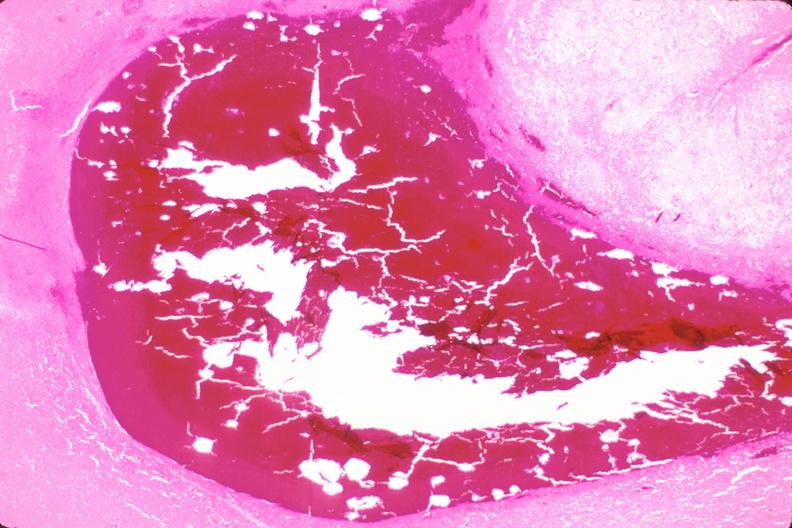s nervous present?
Answer the question using a single word or phrase. Yes 